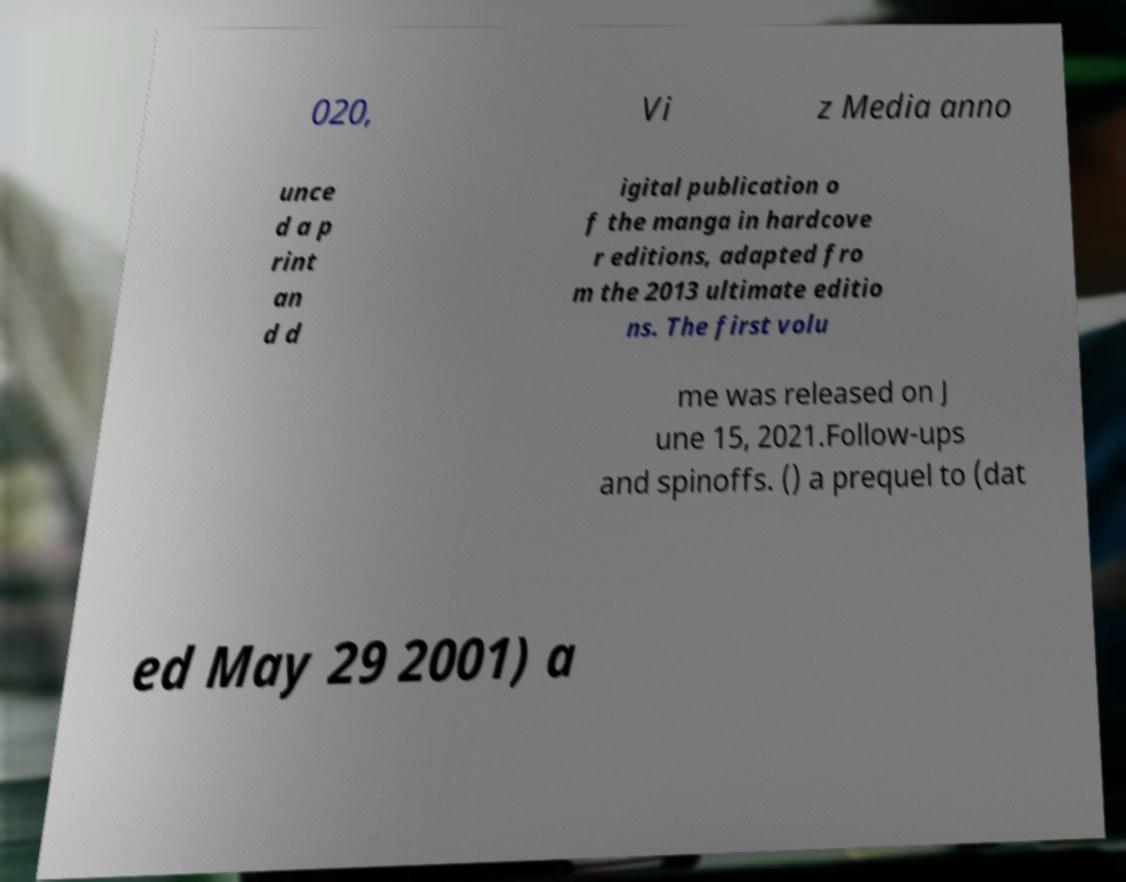Could you assist in decoding the text presented in this image and type it out clearly? 020, Vi z Media anno unce d a p rint an d d igital publication o f the manga in hardcove r editions, adapted fro m the 2013 ultimate editio ns. The first volu me was released on J une 15, 2021.Follow-ups and spinoffs. () a prequel to (dat ed May 29 2001) a 